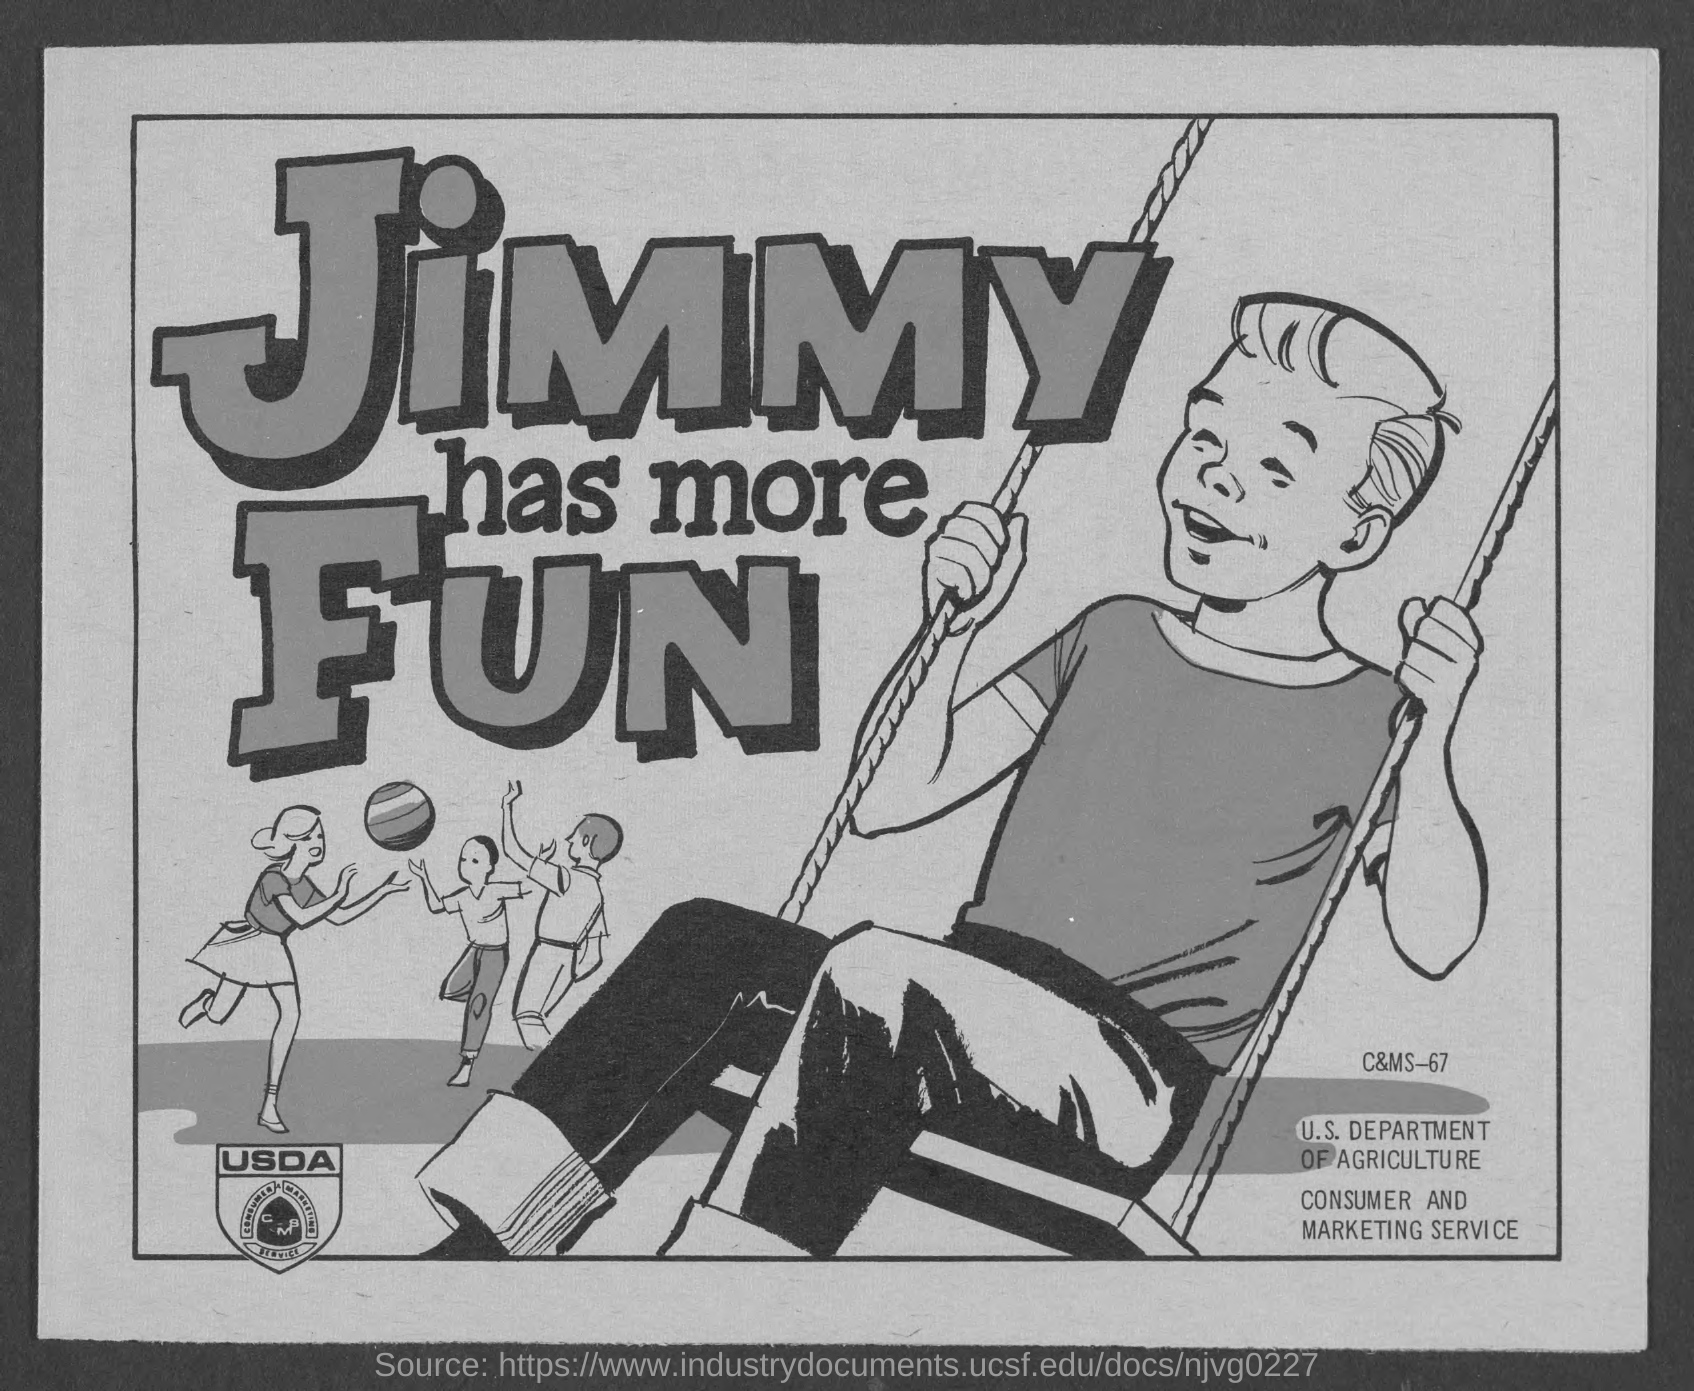What is c&ms no.?
Give a very brief answer. 67. 